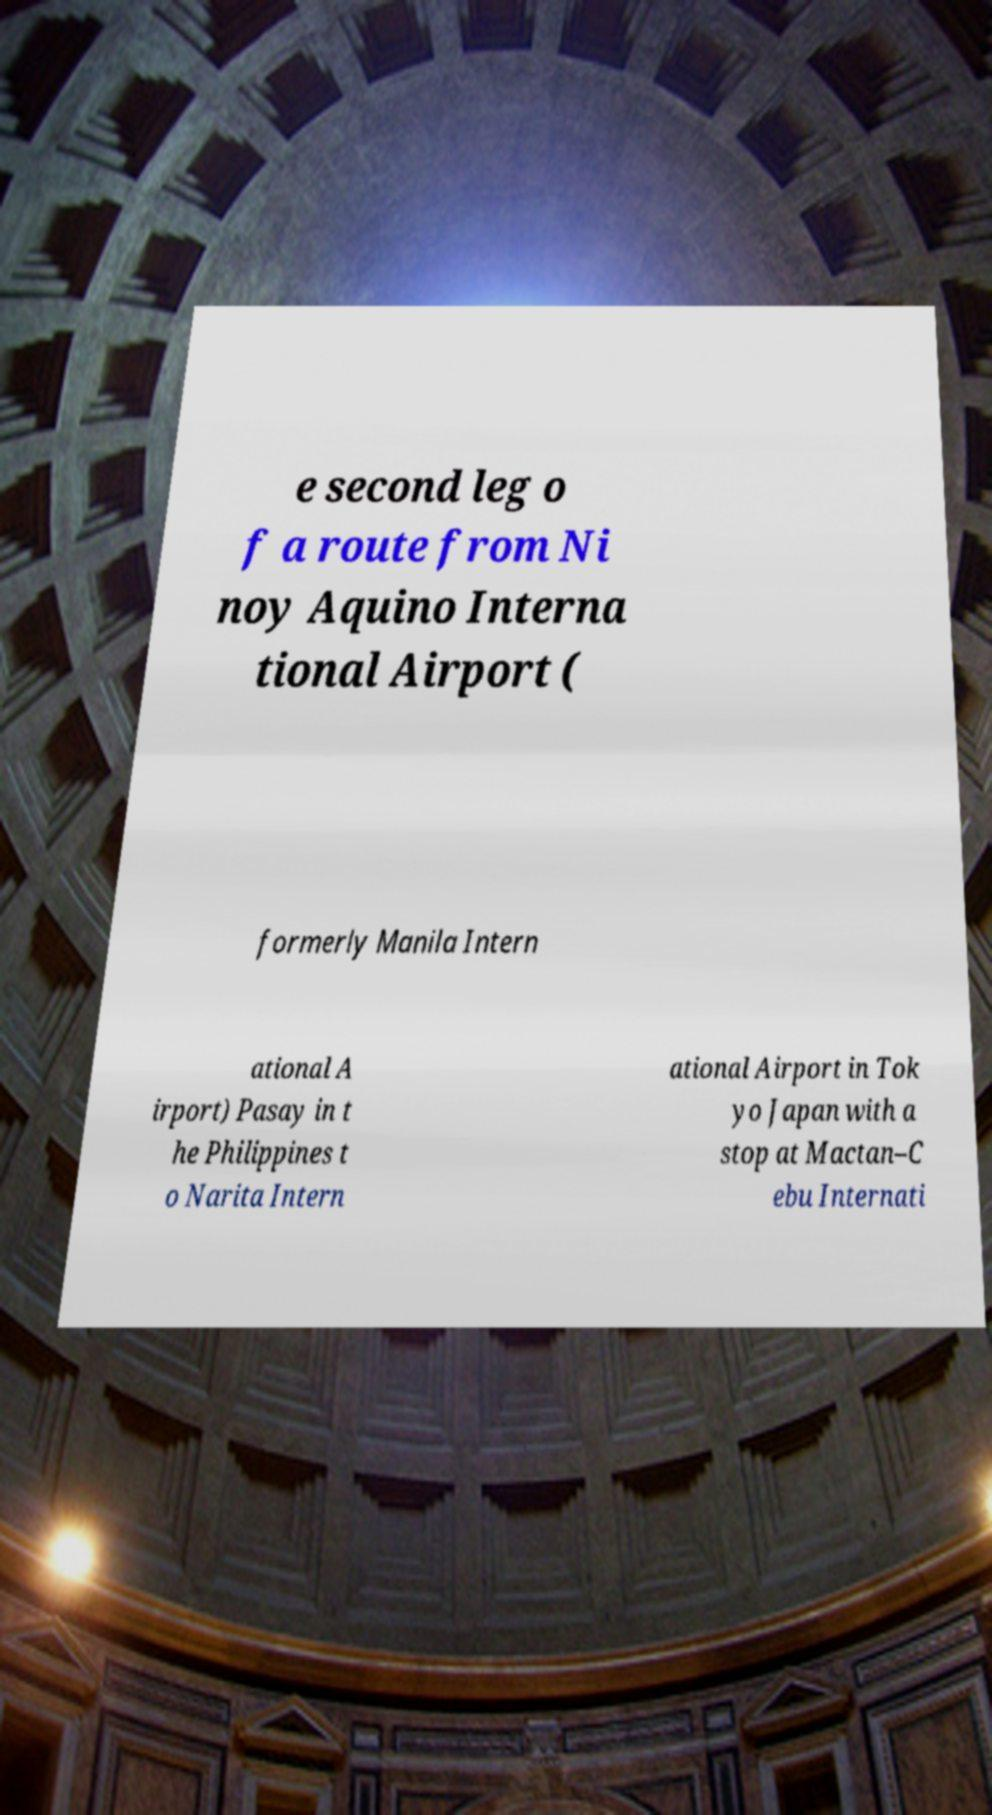What messages or text are displayed in this image? I need them in a readable, typed format. e second leg o f a route from Ni noy Aquino Interna tional Airport ( formerly Manila Intern ational A irport) Pasay in t he Philippines t o Narita Intern ational Airport in Tok yo Japan with a stop at Mactan–C ebu Internati 